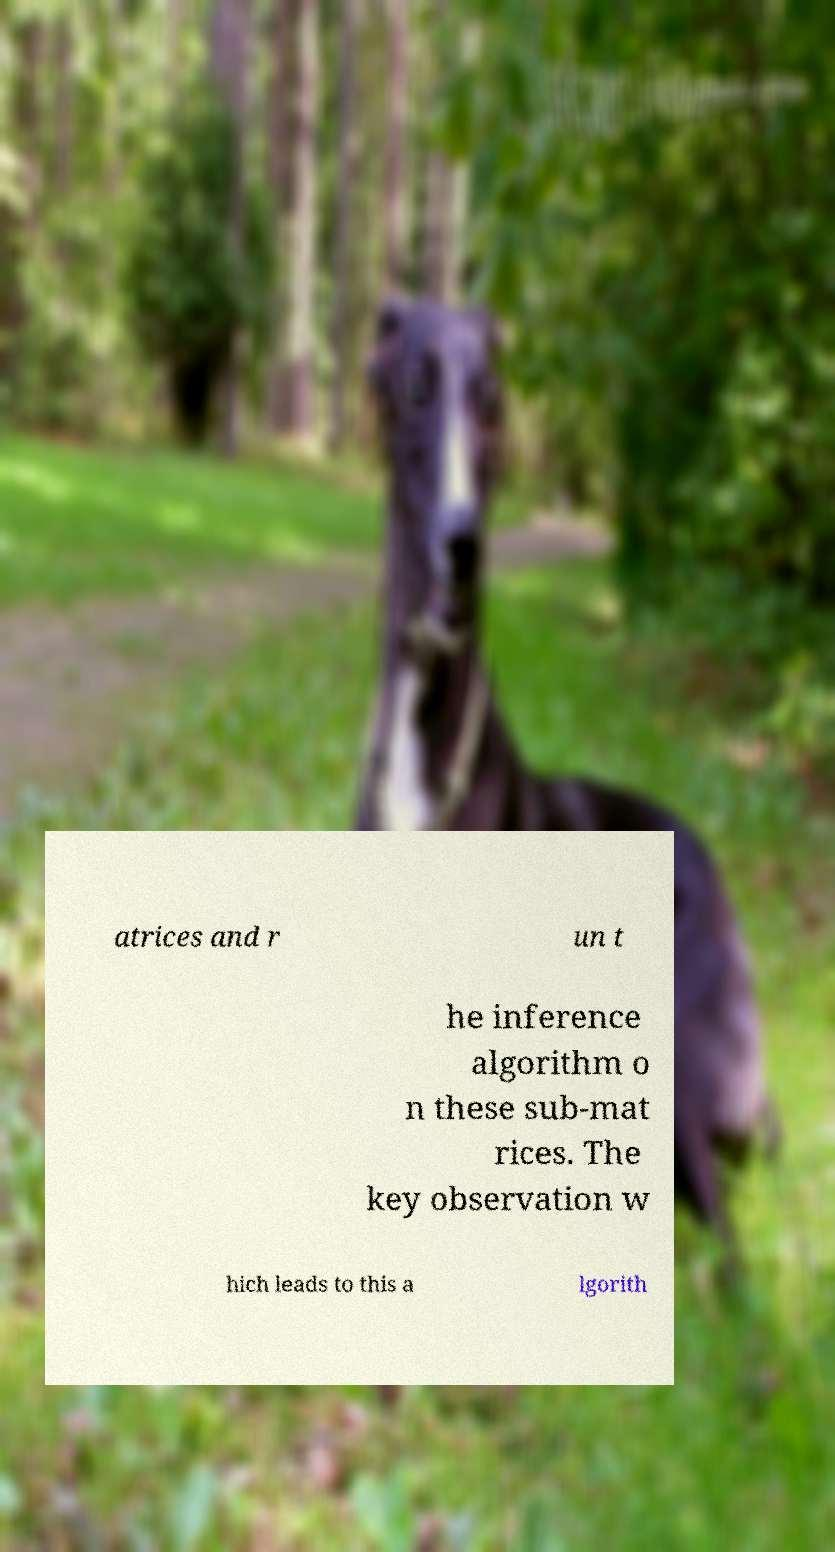Can you read and provide the text displayed in the image?This photo seems to have some interesting text. Can you extract and type it out for me? atrices and r un t he inference algorithm o n these sub-mat rices. The key observation w hich leads to this a lgorith 